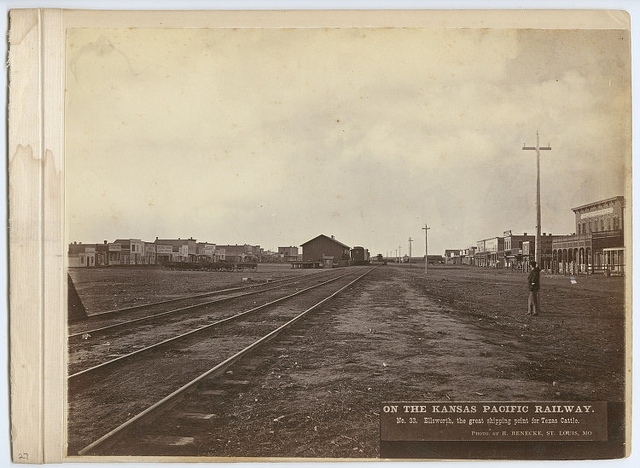Identify the text contained in this image. ON THE KANSAS PACIFIC RAILWAY 